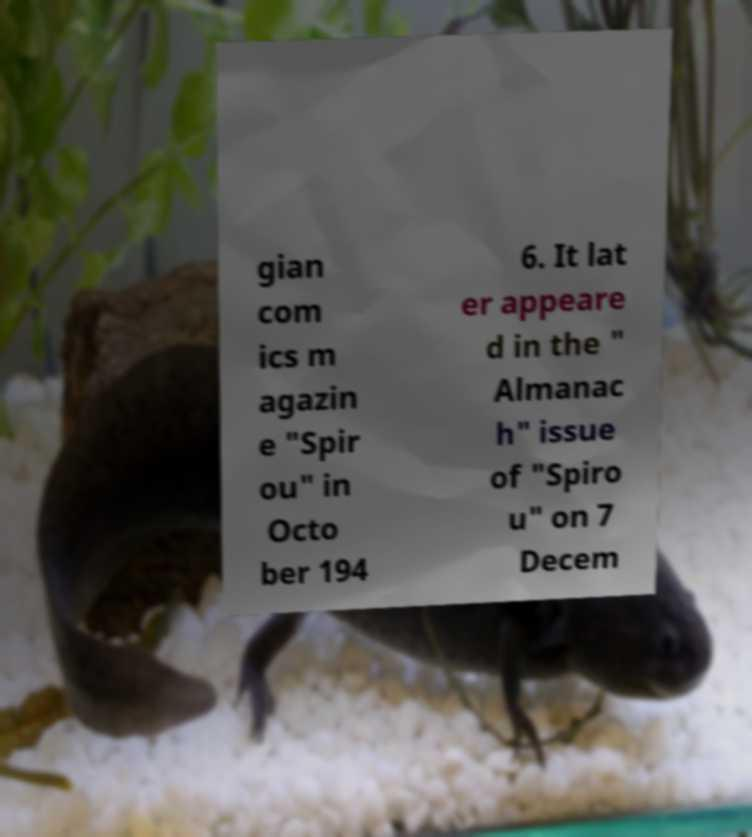Could you extract and type out the text from this image? gian com ics m agazin e "Spir ou" in Octo ber 194 6. It lat er appeare d in the " Almanac h" issue of "Spiro u" on 7 Decem 